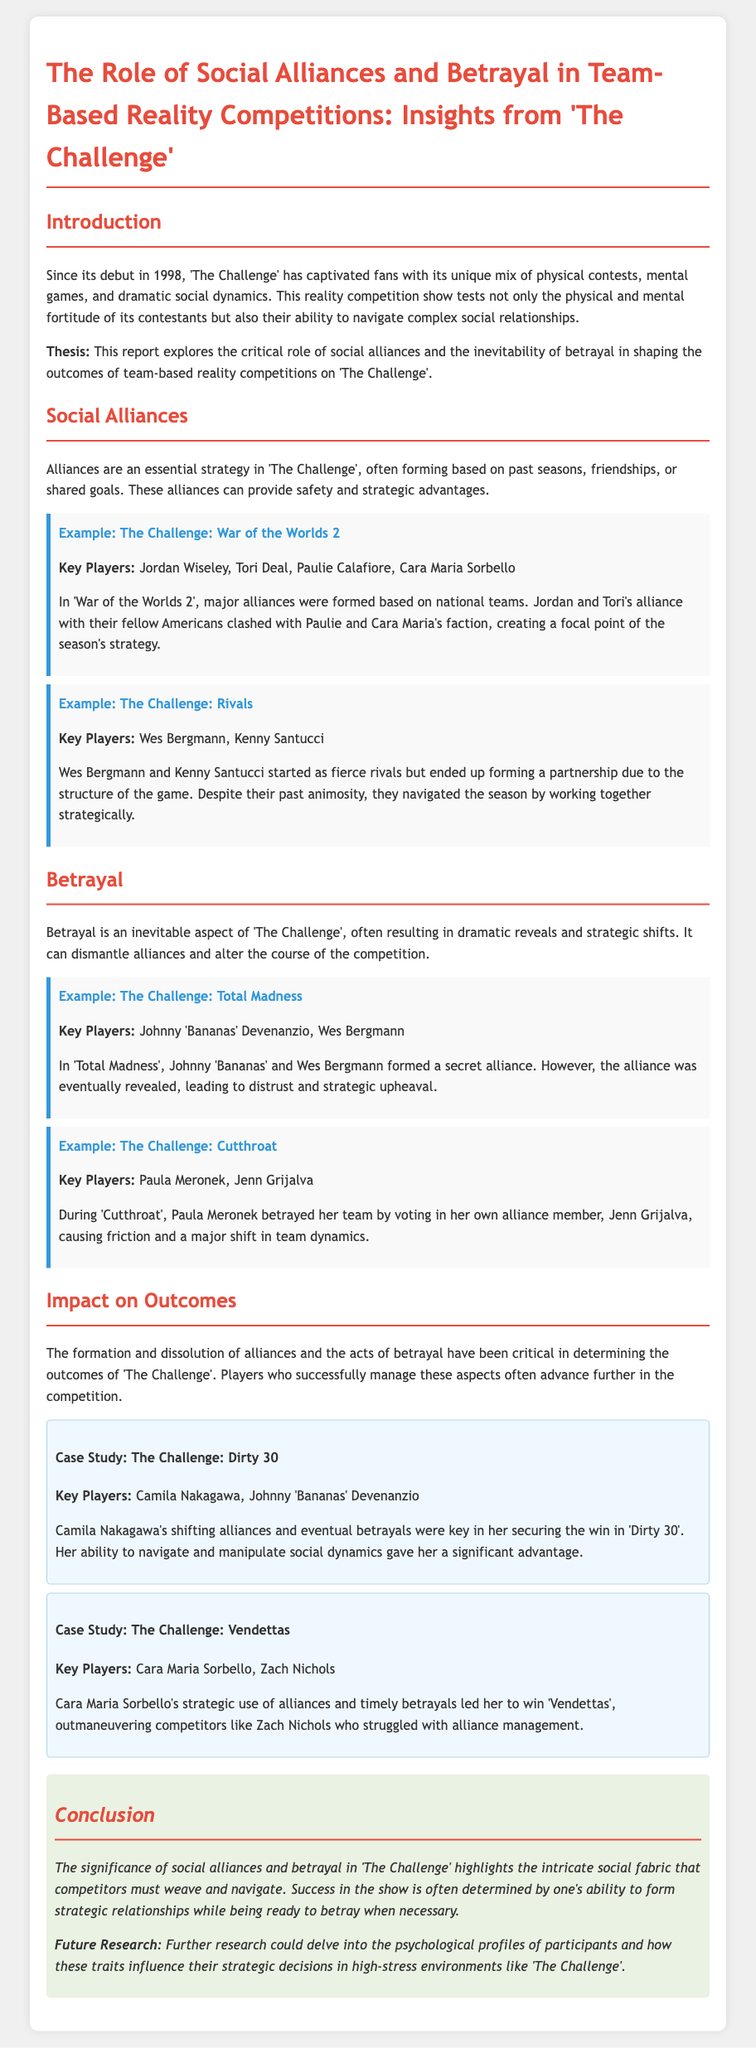What is the thesis of the report? The thesis can be found in the introduction and highlights the critical role of social alliances and betrayal in 'The Challenge'.
Answer: This report explores the critical role of social alliances and the inevitability of betrayal in shaping the outcomes of team-based reality competitions on 'The Challenge' Who are the key players in 'The Challenge: War of the Worlds 2'? The document provides key players from specific examples. The key players in this example are listed.
Answer: Jordan Wiseley, Tori Deal, Paulie Calafiore, Cara Maria Sorbello What are social alliances described as in the report? The report defines social alliances as a strategy that contestants use to gain advantages.
Answer: An essential strategy Which season features the secret alliance between Johnny 'Bananas' and Wes Bergmann? The text specifies a particular season where this alliance occurred, helping to identify it.
Answer: Total Madness What major shift did Paula Meronek create during 'Cutthroat'? The document explains the impact of her action on team dynamics, which is specified in her example.
Answer: Causing friction and a major shift in team dynamics Who won 'Vendettas' according to the case study? The report names the winner in the case study relating to 'Vendettas'.
Answer: Cara Maria Sorbello What could future research explore according to the conclusion? The conclusion mentions a direction for further research that aligns with the document's themes.
Answer: Psychological profiles of participants How is betrayal characterized in 'The Challenge'? The document describes betrayal and its impacts on the competition in a specific context.
Answer: An inevitable aspect 